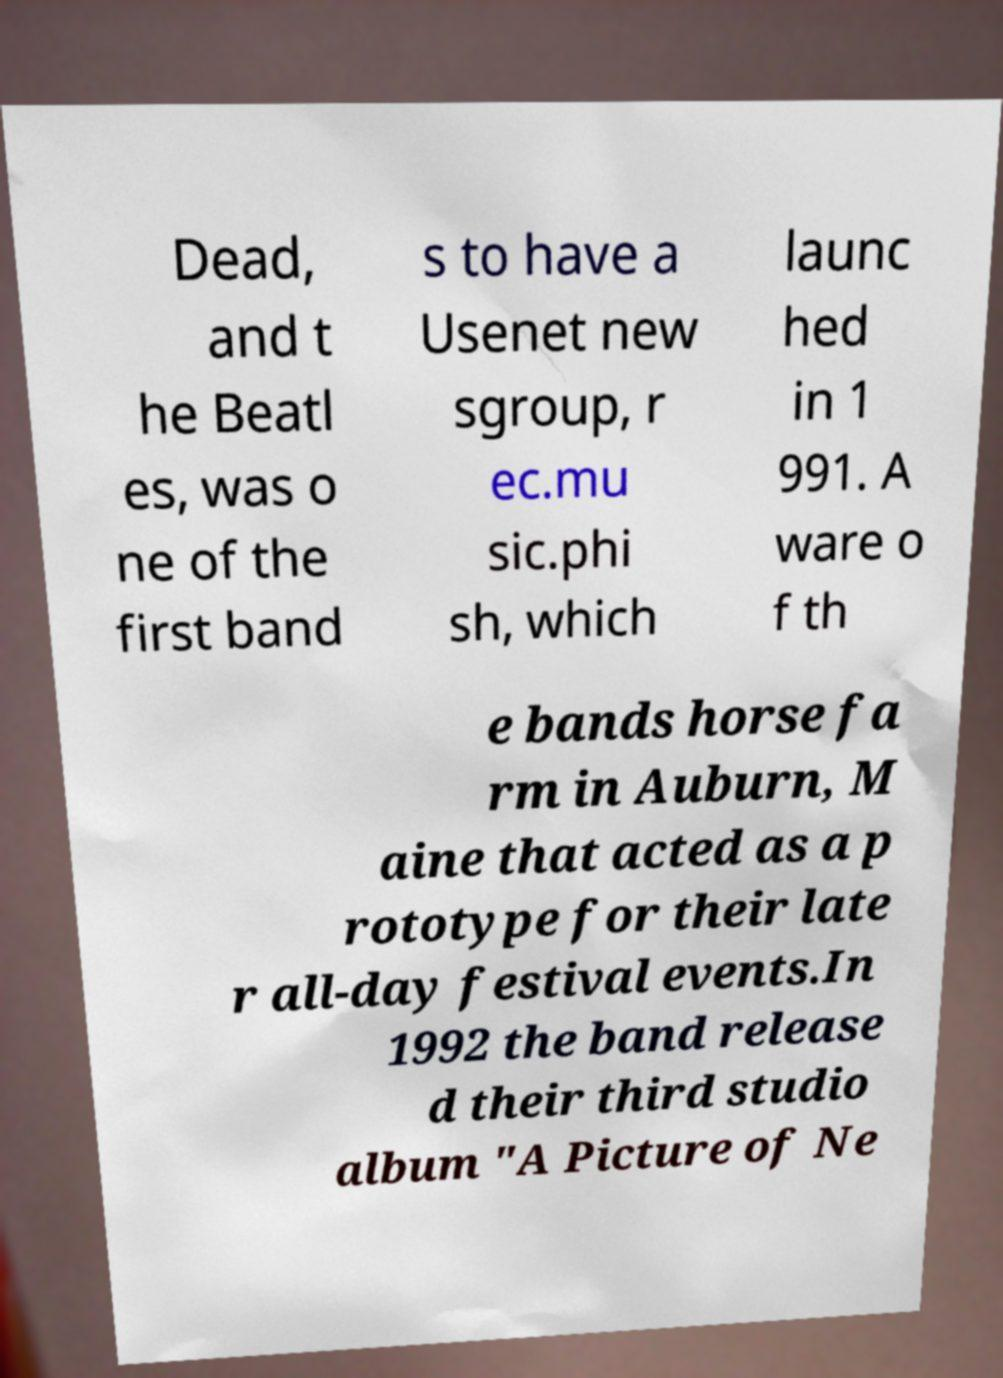Could you assist in decoding the text presented in this image and type it out clearly? Dead, and t he Beatl es, was o ne of the first band s to have a Usenet new sgroup, r ec.mu sic.phi sh, which launc hed in 1 991. A ware o f th e bands horse fa rm in Auburn, M aine that acted as a p rototype for their late r all-day festival events.In 1992 the band release d their third studio album "A Picture of Ne 